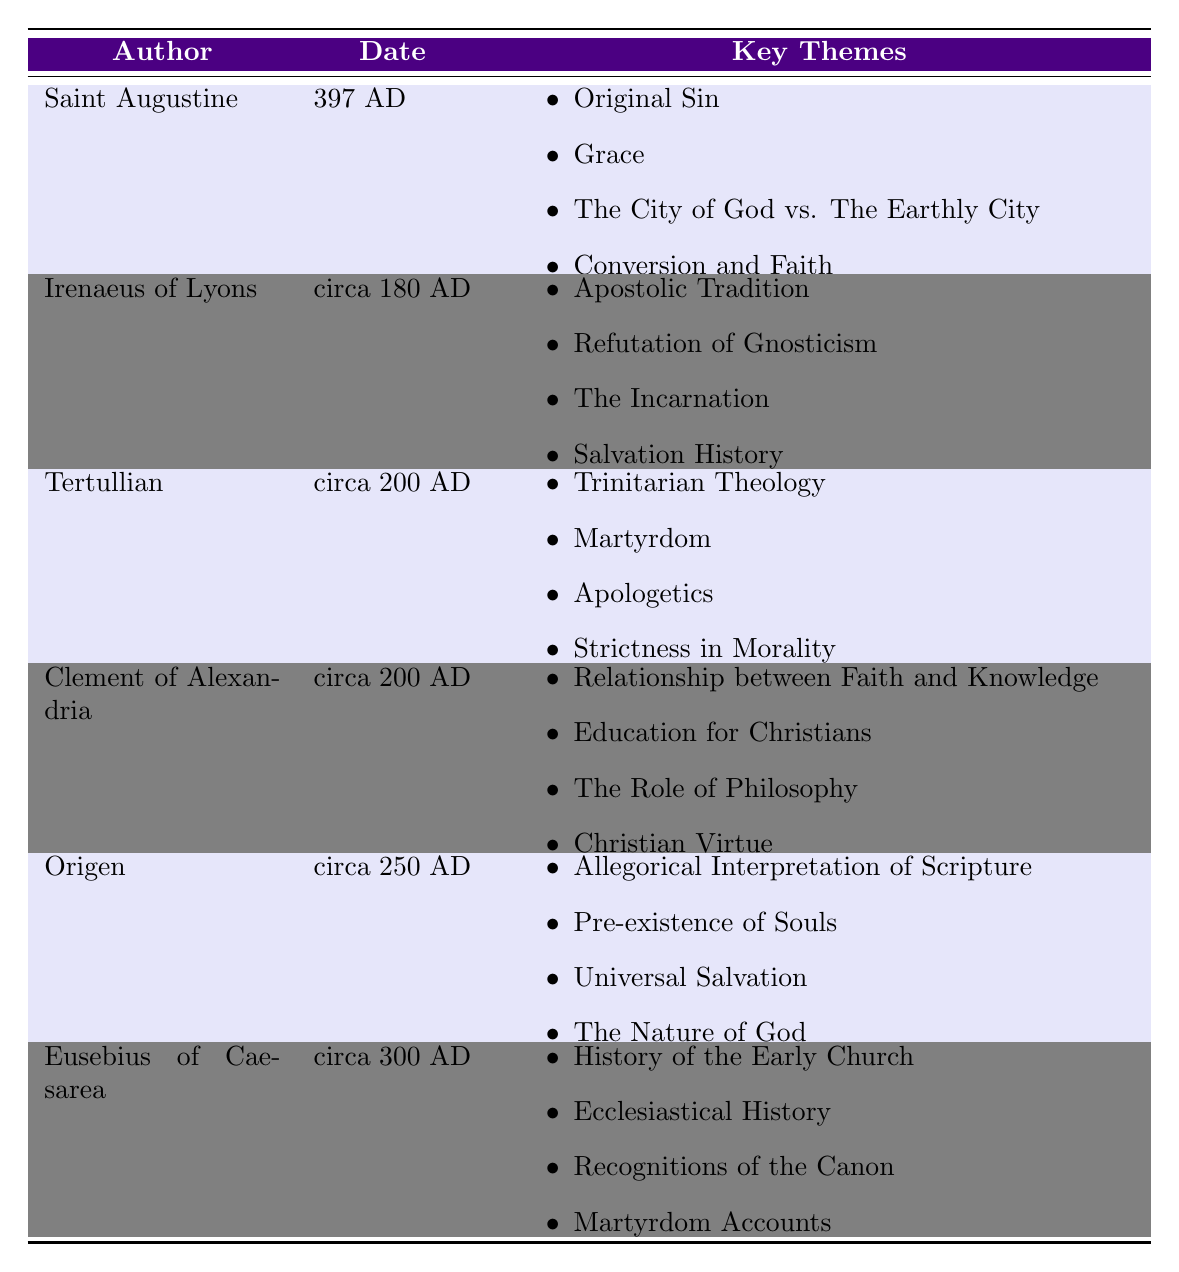What is the date of the writing by Saint Augustine? The table lists the writings with their respective authors and dates. For Saint Augustine, the date provided is 397 AD.
Answer: 397 AD What are the key themes of Tertullian's writings? To find this, I look under Tertullian in the "Key Themes" column, which lists Trinitarian Theology, Martyrdom, Apologetics, and Strictness in Morality.
Answer: Trinitarian Theology, Martyrdom, Apologetics, Strictness in Morality Who authored the writings around 200 AD? The table indicates that both Tertullian and Clement of Alexandria have writings dated around 200 AD.
Answer: Tertullian and Clement of Alexandria Which author focused on Apostolic Tradition? By reviewing the table, under "Authorship," I see that Irenaeus of Lyons is associated with the theme of Apostolic Tradition.
Answer: Irenaeus of Lyons What are the key themes shared by authors from the second century? I notice that both Irenaeus of Lyons and Tertullian, who are from that century, emphasize different themes. Irenaeus' themes are related to Apostolic Tradition and refuting Gnosticism, while Tertullian discusses Trinitarian Theology and Martyrdom.
Answer: They emphasize different themes without shared specific themes Is it true that Eusebius of Caesarea wrote about the history of the Early Church? The table directly lists Eusebius of Caesarea with the key theme "History of the Early Church," confirming the statement as true.
Answer: True Which themes are unique to Origen's writings? By reviewing the key themes for Origen and comparing them to others, I find Allegorical Interpretation of Scripture, Pre-existence of Souls, Universal Salvation, and The Nature of God, which are not listed for other authors.
Answer: Allegorical Interpretation of Scripture, Pre-existence of Souls, Universal Salvation, The Nature of God What is the chronological order of the authors based on their writing dates? The authors can be arranged by their dates: Irenaeus of Lyons (circa 180 AD), Tertullian and Clement of Alexandria (circa 200 AD), Origen (circa 250 AD), and Eusebius of Caesarea (circa 300 AD). This arrangement shows the progression over time.
Answer: Irenaeus of Lyons, Tertullian, Clement of Alexandria, Origen, Eusebius of Caesarea Which author is associated with the theme of Grace? Referring to the key themes associated with each author, I find that Saint Augustine has the theme of Grace listed.
Answer: Saint Augustine Do both Tertullian and Clement of Alexandria write about Christian morality? Tertullian includes "Strictness in Morality" as a key theme, while Clement discusses "Christian Virtue," indicating that both authors do indeed write about aspects related to Christian morality.
Answer: Yes What can be inferred about the progression of themes from early to late writings? Reviewing the themes, one may infer that earlier writings (such as those of Irenaeus) emphasize core doctrinal elements like Apostolic Tradition and refutation of heresies, while later authors like Origen and Eusebius include more complex theological interpretations, indicating a growth in theological exploration and historical context.
Answer: The themes evolved towards more complex interpretations and historical context 